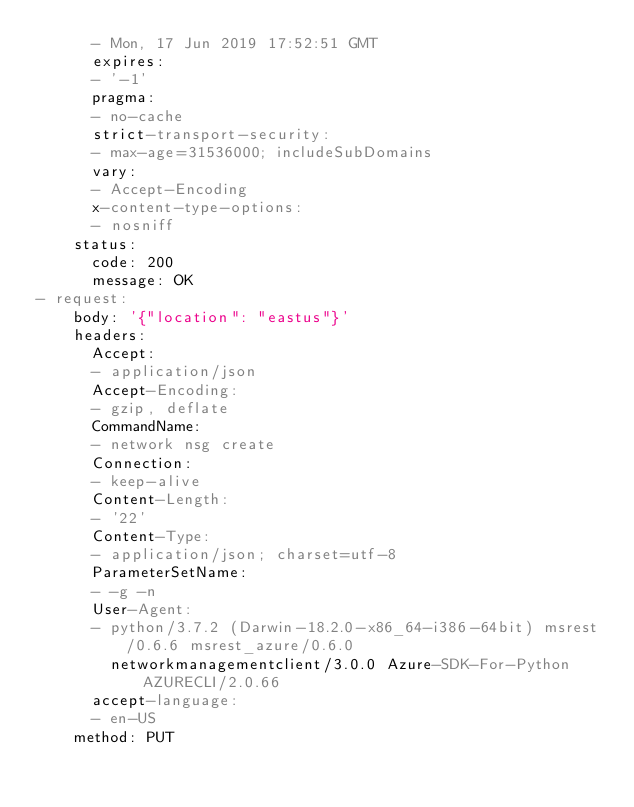<code> <loc_0><loc_0><loc_500><loc_500><_YAML_>      - Mon, 17 Jun 2019 17:52:51 GMT
      expires:
      - '-1'
      pragma:
      - no-cache
      strict-transport-security:
      - max-age=31536000; includeSubDomains
      vary:
      - Accept-Encoding
      x-content-type-options:
      - nosniff
    status:
      code: 200
      message: OK
- request:
    body: '{"location": "eastus"}'
    headers:
      Accept:
      - application/json
      Accept-Encoding:
      - gzip, deflate
      CommandName:
      - network nsg create
      Connection:
      - keep-alive
      Content-Length:
      - '22'
      Content-Type:
      - application/json; charset=utf-8
      ParameterSetName:
      - -g -n
      User-Agent:
      - python/3.7.2 (Darwin-18.2.0-x86_64-i386-64bit) msrest/0.6.6 msrest_azure/0.6.0
        networkmanagementclient/3.0.0 Azure-SDK-For-Python AZURECLI/2.0.66
      accept-language:
      - en-US
    method: PUT</code> 